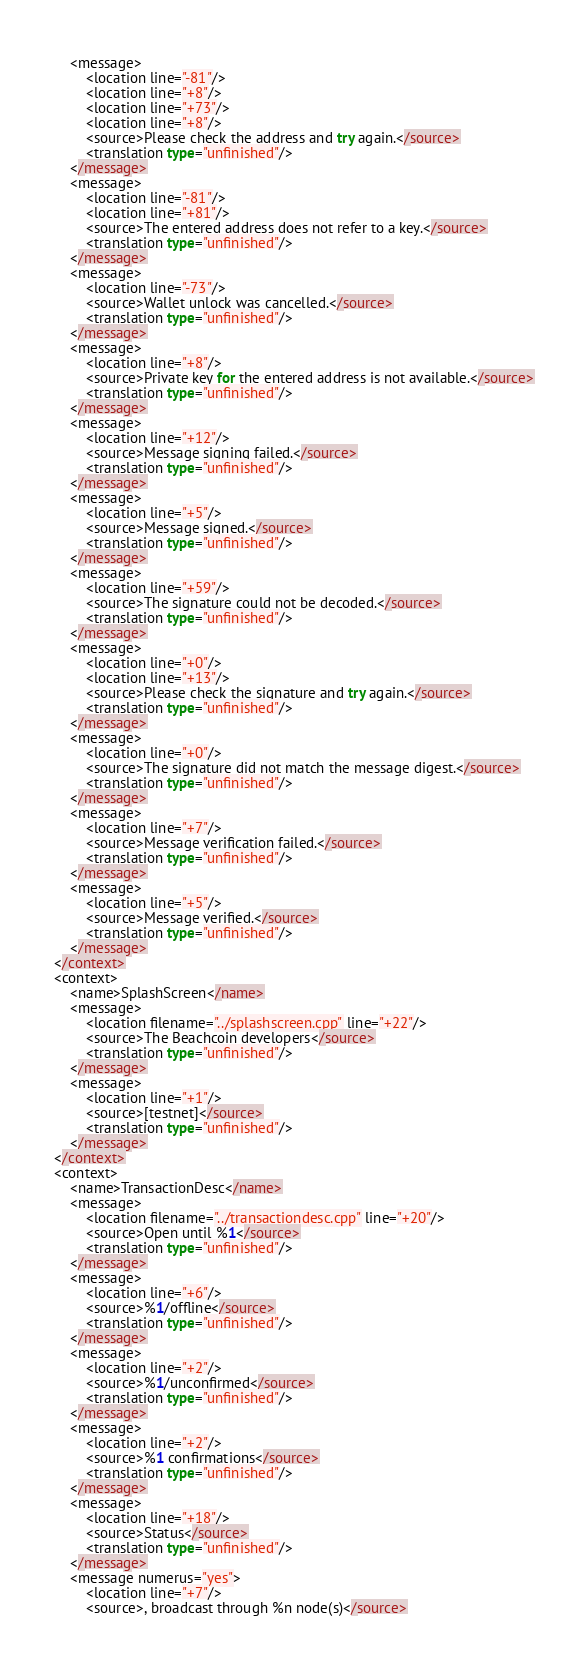<code> <loc_0><loc_0><loc_500><loc_500><_TypeScript_>    <message>
        <location line="-81"/>
        <location line="+8"/>
        <location line="+73"/>
        <location line="+8"/>
        <source>Please check the address and try again.</source>
        <translation type="unfinished"/>
    </message>
    <message>
        <location line="-81"/>
        <location line="+81"/>
        <source>The entered address does not refer to a key.</source>
        <translation type="unfinished"/>
    </message>
    <message>
        <location line="-73"/>
        <source>Wallet unlock was cancelled.</source>
        <translation type="unfinished"/>
    </message>
    <message>
        <location line="+8"/>
        <source>Private key for the entered address is not available.</source>
        <translation type="unfinished"/>
    </message>
    <message>
        <location line="+12"/>
        <source>Message signing failed.</source>
        <translation type="unfinished"/>
    </message>
    <message>
        <location line="+5"/>
        <source>Message signed.</source>
        <translation type="unfinished"/>
    </message>
    <message>
        <location line="+59"/>
        <source>The signature could not be decoded.</source>
        <translation type="unfinished"/>
    </message>
    <message>
        <location line="+0"/>
        <location line="+13"/>
        <source>Please check the signature and try again.</source>
        <translation type="unfinished"/>
    </message>
    <message>
        <location line="+0"/>
        <source>The signature did not match the message digest.</source>
        <translation type="unfinished"/>
    </message>
    <message>
        <location line="+7"/>
        <source>Message verification failed.</source>
        <translation type="unfinished"/>
    </message>
    <message>
        <location line="+5"/>
        <source>Message verified.</source>
        <translation type="unfinished"/>
    </message>
</context>
<context>
    <name>SplashScreen</name>
    <message>
        <location filename="../splashscreen.cpp" line="+22"/>
        <source>The Beachcoin developers</source>
        <translation type="unfinished"/>
    </message>
    <message>
        <location line="+1"/>
        <source>[testnet]</source>
        <translation type="unfinished"/>
    </message>
</context>
<context>
    <name>TransactionDesc</name>
    <message>
        <location filename="../transactiondesc.cpp" line="+20"/>
        <source>Open until %1</source>
        <translation type="unfinished"/>
    </message>
    <message>
        <location line="+6"/>
        <source>%1/offline</source>
        <translation type="unfinished"/>
    </message>
    <message>
        <location line="+2"/>
        <source>%1/unconfirmed</source>
        <translation type="unfinished"/>
    </message>
    <message>
        <location line="+2"/>
        <source>%1 confirmations</source>
        <translation type="unfinished"/>
    </message>
    <message>
        <location line="+18"/>
        <source>Status</source>
        <translation type="unfinished"/>
    </message>
    <message numerus="yes">
        <location line="+7"/>
        <source>, broadcast through %n node(s)</source></code> 